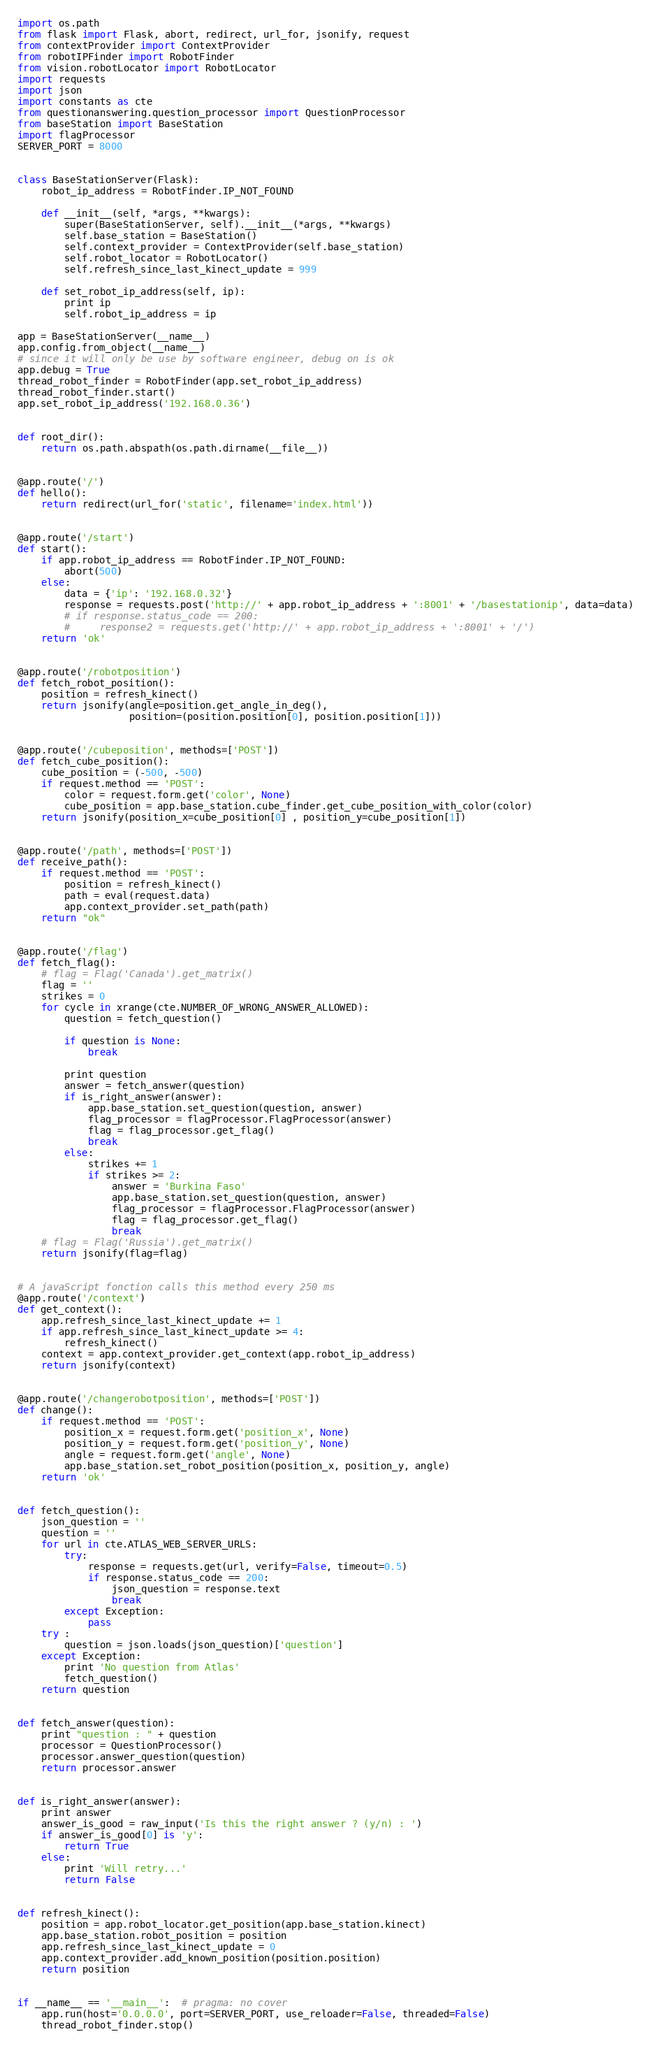<code> <loc_0><loc_0><loc_500><loc_500><_Python_>import os.path
from flask import Flask, abort, redirect, url_for, jsonify, request
from contextProvider import ContextProvider
from robotIPFinder import RobotFinder
from vision.robotLocator import RobotLocator
import requests
import json
import constants as cte
from questionanswering.question_processor import QuestionProcessor
from baseStation import BaseStation
import flagProcessor
SERVER_PORT = 8000


class BaseStationServer(Flask):
    robot_ip_address = RobotFinder.IP_NOT_FOUND

    def __init__(self, *args, **kwargs):
        super(BaseStationServer, self).__init__(*args, **kwargs)
        self.base_station = BaseStation()
        self.context_provider = ContextProvider(self.base_station)
        self.robot_locator = RobotLocator()
        self.refresh_since_last_kinect_update = 999

    def set_robot_ip_address(self, ip):
        print ip
        self.robot_ip_address = ip

app = BaseStationServer(__name__)
app.config.from_object(__name__)
# since it will only be use by software engineer, debug on is ok
app.debug = True
thread_robot_finder = RobotFinder(app.set_robot_ip_address)
thread_robot_finder.start()
app.set_robot_ip_address('192.168.0.36')


def root_dir():
    return os.path.abspath(os.path.dirname(__file__))


@app.route('/')
def hello():
    return redirect(url_for('static', filename='index.html'))


@app.route('/start')
def start():
    if app.robot_ip_address == RobotFinder.IP_NOT_FOUND:
        abort(500)
    else:
        data = {'ip': '192.168.0.32'}
        response = requests.post('http://' + app.robot_ip_address + ':8001' + '/basestationip', data=data)
        # if response.status_code == 200:
        #     response2 = requests.get('http://' + app.robot_ip_address + ':8001' + '/')
    return 'ok'


@app.route('/robotposition')
def fetch_robot_position():
    position = refresh_kinect()
    return jsonify(angle=position.get_angle_in_deg(),
                   position=(position.position[0], position.position[1]))


@app.route('/cubeposition', methods=['POST'])
def fetch_cube_position():
    cube_position = (-500, -500)
    if request.method == 'POST':
        color = request.form.get('color', None)
        cube_position = app.base_station.cube_finder.get_cube_position_with_color(color)
    return jsonify(position_x=cube_position[0] , position_y=cube_position[1])


@app.route('/path', methods=['POST'])
def receive_path():
    if request.method == 'POST':
        position = refresh_kinect()
        path = eval(request.data)
        app.context_provider.set_path(path)
    return "ok"


@app.route('/flag')
def fetch_flag():
    # flag = Flag('Canada').get_matrix()
    flag = ''
    strikes = 0
    for cycle in xrange(cte.NUMBER_OF_WRONG_ANSWER_ALLOWED):
        question = fetch_question()

        if question is None:
            break

        print question
        answer = fetch_answer(question)
        if is_right_answer(answer):
            app.base_station.set_question(question, answer)
            flag_processor = flagProcessor.FlagProcessor(answer)
            flag = flag_processor.get_flag()
            break
        else:
            strikes += 1
            if strikes >= 2:
                answer = 'Burkina Faso'
                app.base_station.set_question(question, answer)
                flag_processor = flagProcessor.FlagProcessor(answer)
                flag = flag_processor.get_flag()
                break
    # flag = Flag('Russia').get_matrix()
    return jsonify(flag=flag)


# A javaScript fonction calls this method every 250 ms
@app.route('/context')
def get_context():
    app.refresh_since_last_kinect_update += 1
    if app.refresh_since_last_kinect_update >= 4:
        refresh_kinect()
    context = app.context_provider.get_context(app.robot_ip_address)
    return jsonify(context)


@app.route('/changerobotposition', methods=['POST'])
def change():
    if request.method == 'POST':
        position_x = request.form.get('position_x', None)
        position_y = request.form.get('position_y', None)
        angle = request.form.get('angle', None)
        app.base_station.set_robot_position(position_x, position_y, angle)
    return 'ok'


def fetch_question():
    json_question = ''
    question = ''
    for url in cte.ATLAS_WEB_SERVER_URLS:
        try:
            response = requests.get(url, verify=False, timeout=0.5)
            if response.status_code == 200:
                json_question = response.text
                break
        except Exception:
            pass
    try :
        question = json.loads(json_question)['question']
    except Exception:
        print 'No question from Atlas'
        fetch_question()
    return question


def fetch_answer(question):
    print "question : " + question
    processor = QuestionProcessor()
    processor.answer_question(question)
    return processor.answer


def is_right_answer(answer):
    print answer
    answer_is_good = raw_input('Is this the right answer ? (y/n) : ')
    if answer_is_good[0] is 'y':
        return True
    else:
        print 'Will retry...'
        return False


def refresh_kinect():
    position = app.robot_locator.get_position(app.base_station.kinect)
    app.base_station.robot_position = position
    app.refresh_since_last_kinect_update = 0
    app.context_provider.add_known_position(position.position)
    return position


if __name__ == '__main__':  # pragma: no cover
    app.run(host='0.0.0.0', port=SERVER_PORT, use_reloader=False, threaded=False)
    thread_robot_finder.stop()</code> 